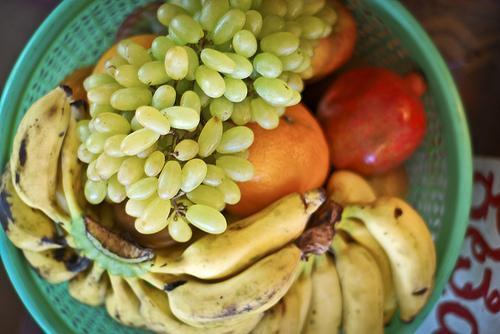How many different fruits are pictured?
Give a very brief answer. 4. How many different fruits are there?
Give a very brief answer. 4. How many apples are there?
Give a very brief answer. 1. How many bananas?
Give a very brief answer. 14. How many different fruits are in the basket?
Give a very brief answer. 4. 